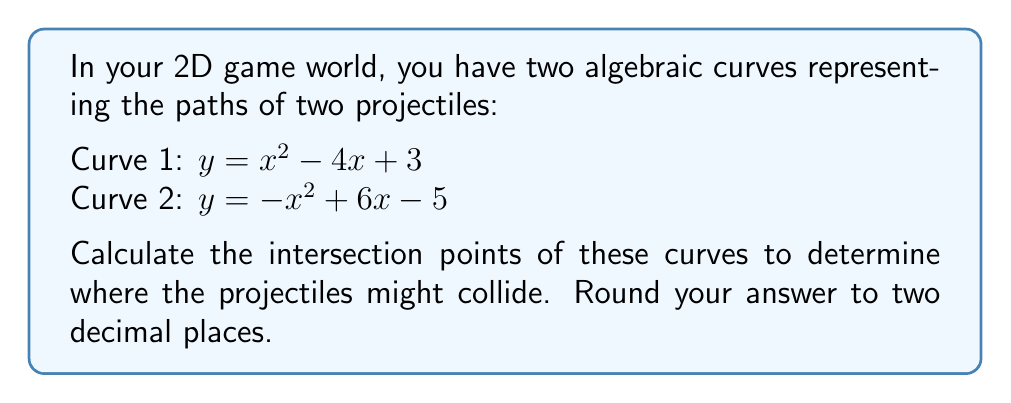Help me with this question. To find the intersection points of these two curves, we need to solve the system of equations:

$$\begin{cases}
y = x^2 - 4x + 3 \\
y = -x^2 + 6x - 5
\end{cases}$$

Step 1: Set the equations equal to each other
$x^2 - 4x + 3 = -x^2 + 6x - 5$

Step 2: Move all terms to one side
$2x^2 - 10x + 8 = 0$

Step 3: Divide all terms by 2 to simplify
$x^2 - 5x + 4 = 0$

Step 4: Use the quadratic formula to solve for x
$x = \frac{-b \pm \sqrt{b^2 - 4ac}}{2a}$

Where $a = 1$, $b = -5$, and $c = 4$

$x = \frac{5 \pm \sqrt{25 - 16}}{2} = \frac{5 \pm 3}{2}$

Step 5: Calculate the two x-values
$x_1 = \frac{5 + 3}{2} = 4$
$x_2 = \frac{5 - 3}{2} = 1$

Step 6: Find the corresponding y-values by substituting x into either of the original equations
For $x_1 = 4$:
$y_1 = 4^2 - 4(4) + 3 = 16 - 16 + 3 = 3$

For $x_2 = 1$:
$y_2 = 1^2 - 4(1) + 3 = 1 - 4 + 3 = 0$

Therefore, the intersection points are (4, 3) and (1, 0).
Answer: (4.00, 3.00) and (1.00, 0.00) 